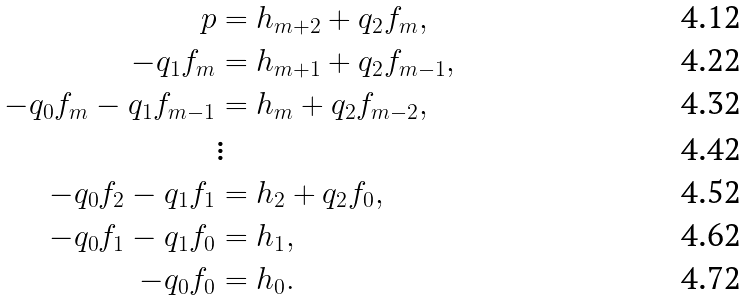Convert formula to latex. <formula><loc_0><loc_0><loc_500><loc_500>p & = h _ { m + 2 } + q _ { 2 } f _ { m } , \\ - q _ { 1 } f _ { m } & = h _ { m + 1 } + q _ { 2 } f _ { m - 1 } , \\ - q _ { 0 } f _ { m } - q _ { 1 } f _ { m - 1 } & = h _ { m } + q _ { 2 } f _ { m - 2 } , \\ & \vdots \\ - q _ { 0 } f _ { 2 } - q _ { 1 } f _ { 1 } & = h _ { 2 } + q _ { 2 } f _ { 0 } , \\ - q _ { 0 } f _ { 1 } - q _ { 1 } f _ { 0 } & = h _ { 1 } , \\ - q _ { 0 } f _ { 0 } & = h _ { 0 } .</formula> 